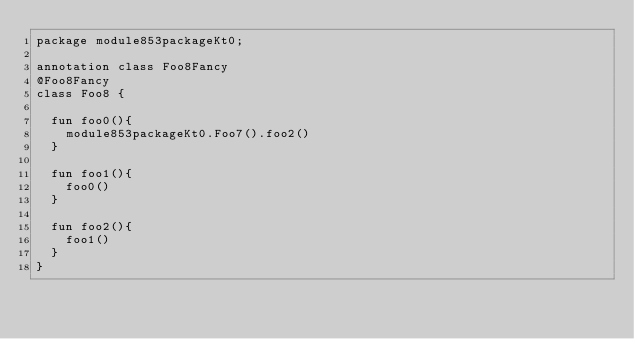<code> <loc_0><loc_0><loc_500><loc_500><_Kotlin_>package module853packageKt0;

annotation class Foo8Fancy
@Foo8Fancy
class Foo8 {

  fun foo0(){
    module853packageKt0.Foo7().foo2()
  }

  fun foo1(){
    foo0()
  }

  fun foo2(){
    foo1()
  }
}</code> 